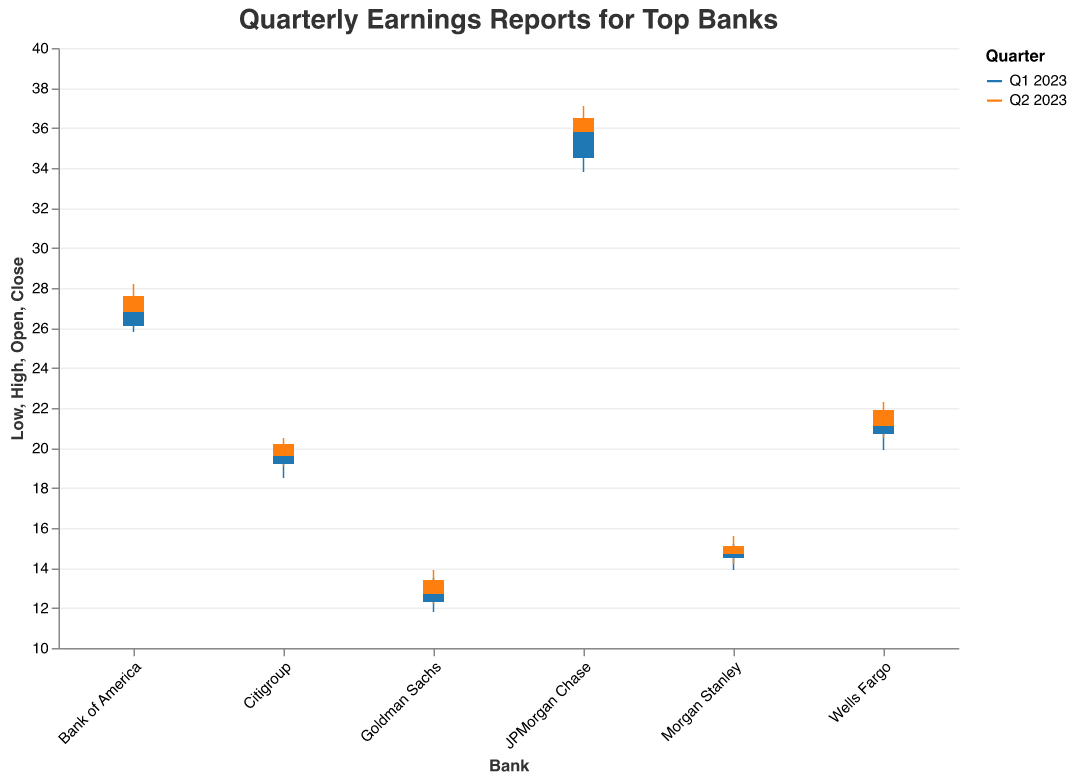Which bank had the highest closing revenue in Q1 2023? To find the highest closing revenue in Q1 2023, look at the "Close" values for each bank for Q1 2023. JPMorgan Chase has the highest closing revenue of 35.9.
Answer: JPMorgan Chase Which bank experienced the largest range between high and low values in Q2 2023? To determine the largest range, calculate the difference between the "High" and "Low" values for each bank in Q2 2023. Goldman Sachs had the largest range (1.7) in Q2 2023.
Answer: Goldman Sachs How did the closing values of JPMorgan Chase change from Q1 2023 to Q2 2023? Compare the closing values of JPMorgan Chase between the two quarters. The closing value increased from 35.9 in Q1 2023 to 36.5 in Q2 2023.
Answer: Increased Which quarter had higher revenues for Bank of America, and what was the difference in their closing values? Compare the closing values of Bank of America between Q1 2023 and Q2 2023. The closing value increased from 26.9 in Q1 2023 to 27.6 in Q2 2023. The difference is 27.6 - 26.9 = 0.7.
Answer: Q2 2023, 0.7 For Wells Fargo in Q2 2023, was the closing value higher or lower than the opening value? Compare the opening value (21.1) with the closing value (21.9) for Wells Fargo in Q2 2023. The closing value was higher.
Answer: Higher Which bank had the lowest opening value in Q2 2023? Look at the "Open" values for each bank in Q2 2023. Goldman Sachs had the lowest opening value of 12.7.
Answer: Goldman Sachs Compare the closing values between Q1 2023 and Q2 2023 for Citigroup. Did it increase or decrease, and by how much? Look at the closing values for Citigroup in Q1 2023 (19.7) and Q2 2023 (20.2). The value increased by 20.2 - 19.7 = 0.5.
Answer: Increased, 0.5 Which banks had an increase in closing value from Q1 2023 to Q2 2023? Compare the Q1 2023 and Q2 2023 closing values for each bank. The banks with increased closing values are JPMorgan Chase, Bank of America, Wells Fargo, Citigroup, Goldman Sachs, and Morgan Stanley.
Answer: All listed banks 